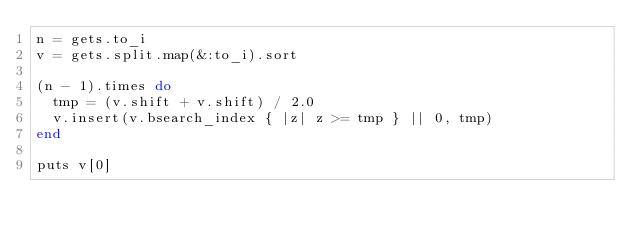Convert code to text. <code><loc_0><loc_0><loc_500><loc_500><_Ruby_>n = gets.to_i
v = gets.split.map(&:to_i).sort

(n - 1).times do
  tmp = (v.shift + v.shift) / 2.0
  v.insert(v.bsearch_index { |z| z >= tmp } || 0, tmp)
end

puts v[0]
</code> 